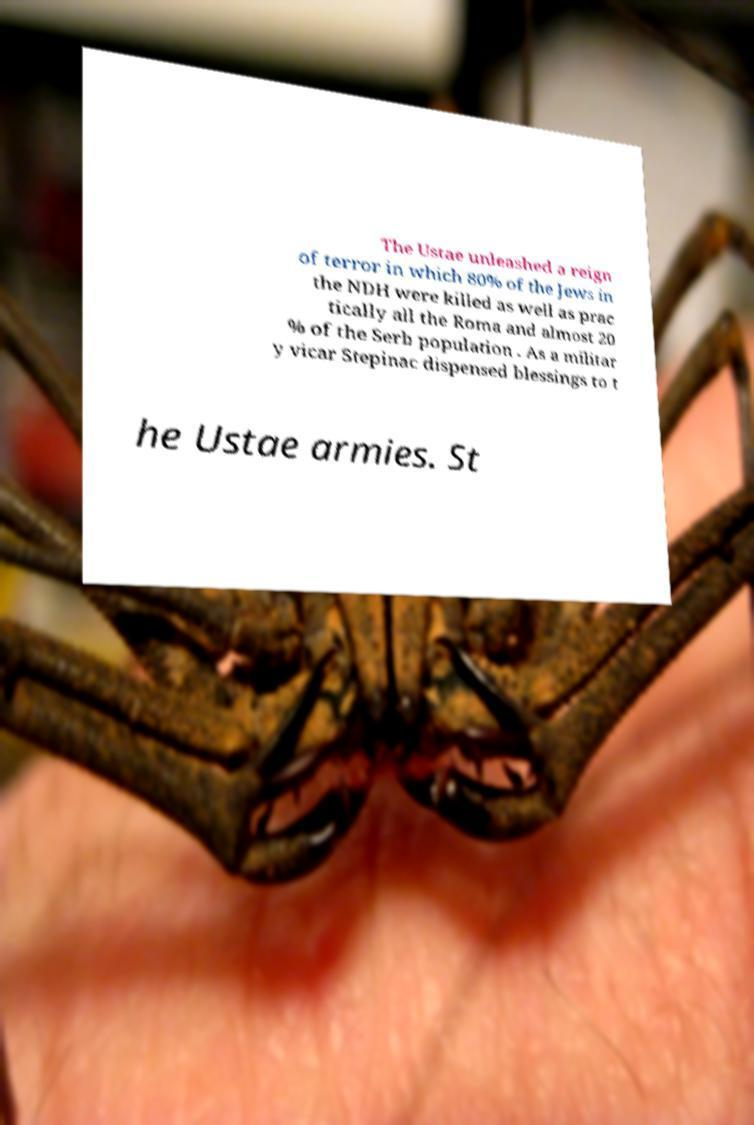I need the written content from this picture converted into text. Can you do that? The Ustae unleashed a reign of terror in which 80% of the Jews in the NDH were killed as well as prac tically all the Roma and almost 20 % of the Serb population . As a militar y vicar Stepinac dispensed blessings to t he Ustae armies. St 